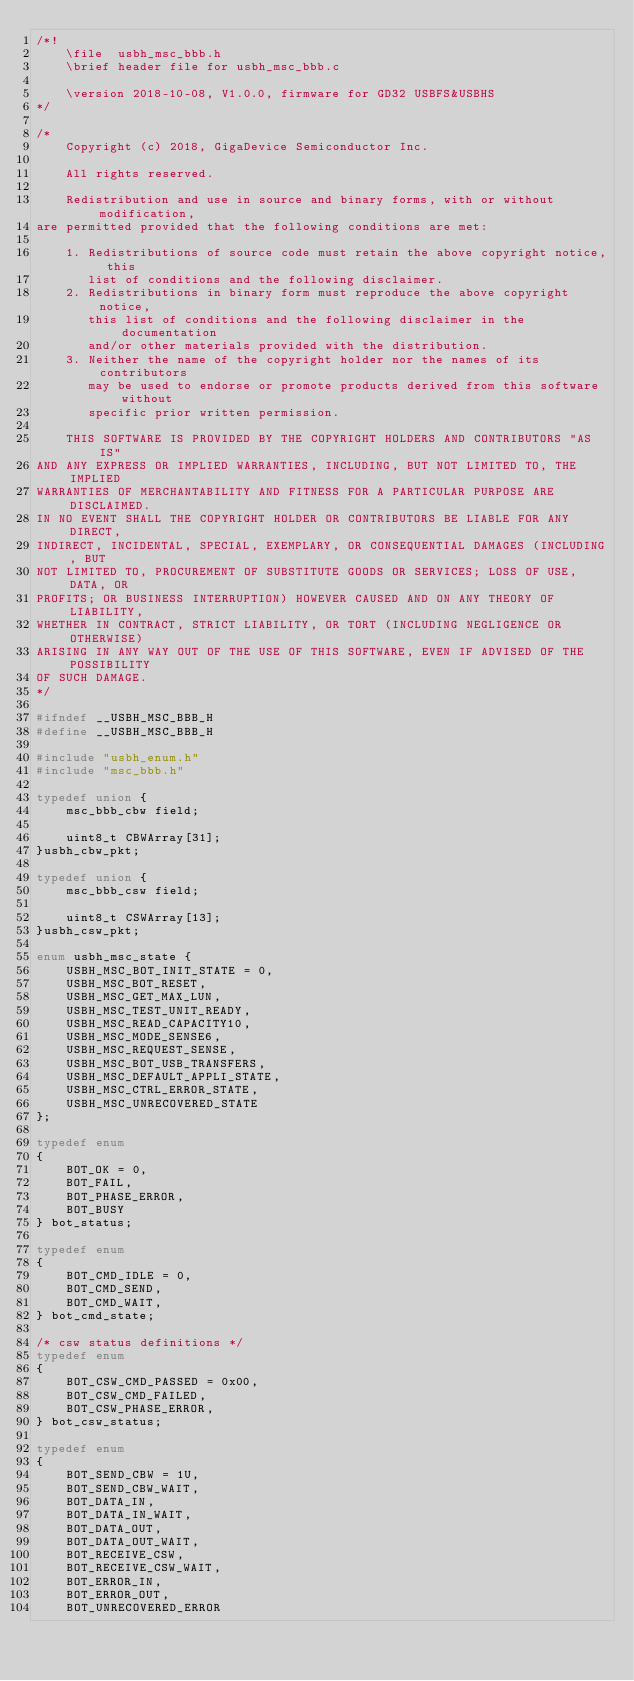<code> <loc_0><loc_0><loc_500><loc_500><_C_>/*!
    \file  usbh_msc_bbb.h
    \brief header file for usbh_msc_bbb.c

    \version 2018-10-08, V1.0.0, firmware for GD32 USBFS&USBHS
*/

/*
    Copyright (c) 2018, GigaDevice Semiconductor Inc.

    All rights reserved.

    Redistribution and use in source and binary forms, with or without modification, 
are permitted provided that the following conditions are met:

    1. Redistributions of source code must retain the above copyright notice, this 
       list of conditions and the following disclaimer.
    2. Redistributions in binary form must reproduce the above copyright notice, 
       this list of conditions and the following disclaimer in the documentation 
       and/or other materials provided with the distribution.
    3. Neither the name of the copyright holder nor the names of its contributors 
       may be used to endorse or promote products derived from this software without 
       specific prior written permission.

    THIS SOFTWARE IS PROVIDED BY THE COPYRIGHT HOLDERS AND CONTRIBUTORS "AS IS" 
AND ANY EXPRESS OR IMPLIED WARRANTIES, INCLUDING, BUT NOT LIMITED TO, THE IMPLIED 
WARRANTIES OF MERCHANTABILITY AND FITNESS FOR A PARTICULAR PURPOSE ARE DISCLAIMED. 
IN NO EVENT SHALL THE COPYRIGHT HOLDER OR CONTRIBUTORS BE LIABLE FOR ANY DIRECT, 
INDIRECT, INCIDENTAL, SPECIAL, EXEMPLARY, OR CONSEQUENTIAL DAMAGES (INCLUDING, BUT 
NOT LIMITED TO, PROCUREMENT OF SUBSTITUTE GOODS OR SERVICES; LOSS OF USE, DATA, OR 
PROFITS; OR BUSINESS INTERRUPTION) HOWEVER CAUSED AND ON ANY THEORY OF LIABILITY, 
WHETHER IN CONTRACT, STRICT LIABILITY, OR TORT (INCLUDING NEGLIGENCE OR OTHERWISE) 
ARISING IN ANY WAY OUT OF THE USE OF THIS SOFTWARE, EVEN IF ADVISED OF THE POSSIBILITY 
OF SUCH DAMAGE.
*/ 

#ifndef __USBH_MSC_BBB_H
#define __USBH_MSC_BBB_H

#include "usbh_enum.h"
#include "msc_bbb.h"

typedef union {
    msc_bbb_cbw field;

    uint8_t CBWArray[31];
}usbh_cbw_pkt;

typedef union {
    msc_bbb_csw field;

    uint8_t CSWArray[13];
}usbh_csw_pkt;

enum usbh_msc_state {
    USBH_MSC_BOT_INIT_STATE = 0,
    USBH_MSC_BOT_RESET,
    USBH_MSC_GET_MAX_LUN,
    USBH_MSC_TEST_UNIT_READY,
    USBH_MSC_READ_CAPACITY10,
    USBH_MSC_MODE_SENSE6,
    USBH_MSC_REQUEST_SENSE,
    USBH_MSC_BOT_USB_TRANSFERS,
    USBH_MSC_DEFAULT_APPLI_STATE,
    USBH_MSC_CTRL_ERROR_STATE,
    USBH_MSC_UNRECOVERED_STATE
};

typedef enum
{
    BOT_OK = 0,
    BOT_FAIL,
    BOT_PHASE_ERROR,
    BOT_BUSY
} bot_status;

typedef enum
{
    BOT_CMD_IDLE = 0,
    BOT_CMD_SEND,
    BOT_CMD_WAIT,
} bot_cmd_state;

/* csw status definitions */
typedef enum
{
    BOT_CSW_CMD_PASSED = 0x00,
    BOT_CSW_CMD_FAILED,
    BOT_CSW_PHASE_ERROR,
} bot_csw_status;

typedef enum
{
    BOT_SEND_CBW = 1U,
    BOT_SEND_CBW_WAIT,
    BOT_DATA_IN,
    BOT_DATA_IN_WAIT,
    BOT_DATA_OUT,
    BOT_DATA_OUT_WAIT,
    BOT_RECEIVE_CSW,
    BOT_RECEIVE_CSW_WAIT,
    BOT_ERROR_IN,
    BOT_ERROR_OUT,
    BOT_UNRECOVERED_ERROR</code> 